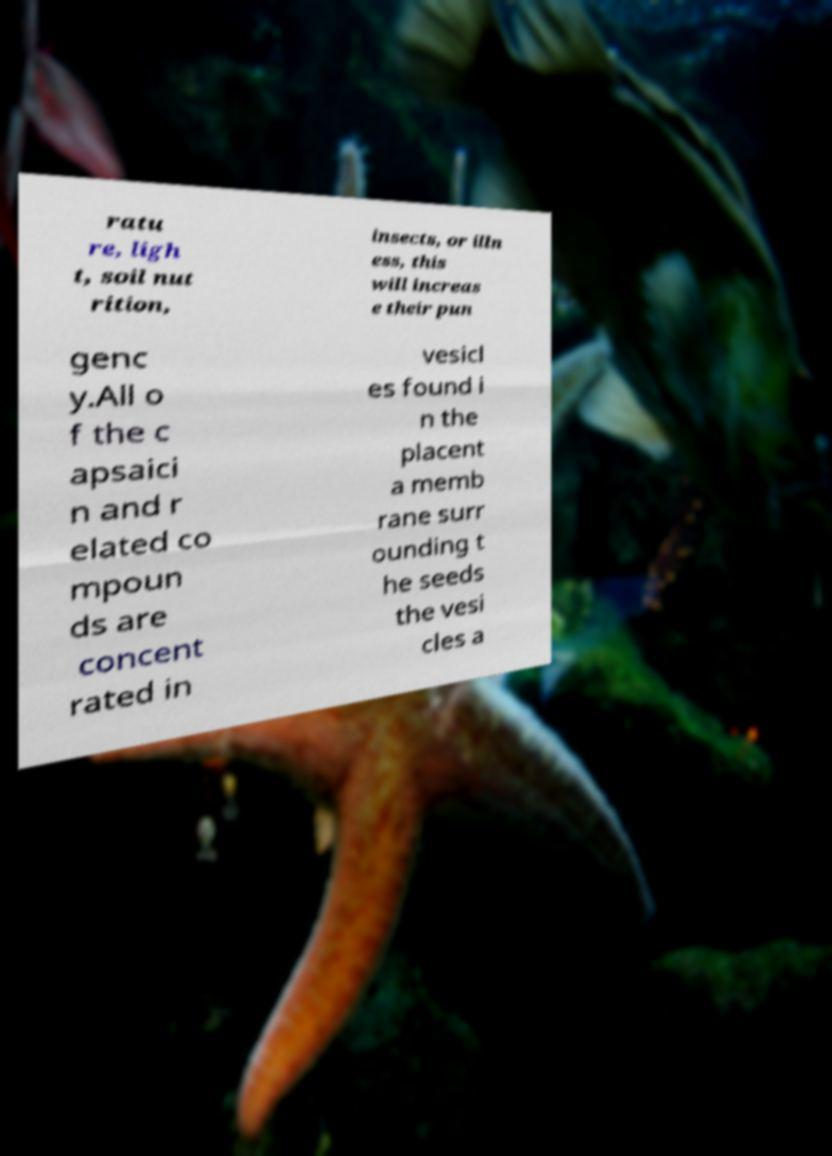Can you accurately transcribe the text from the provided image for me? ratu re, ligh t, soil nut rition, insects, or illn ess, this will increas e their pun genc y.All o f the c apsaici n and r elated co mpoun ds are concent rated in vesicl es found i n the placent a memb rane surr ounding t he seeds the vesi cles a 